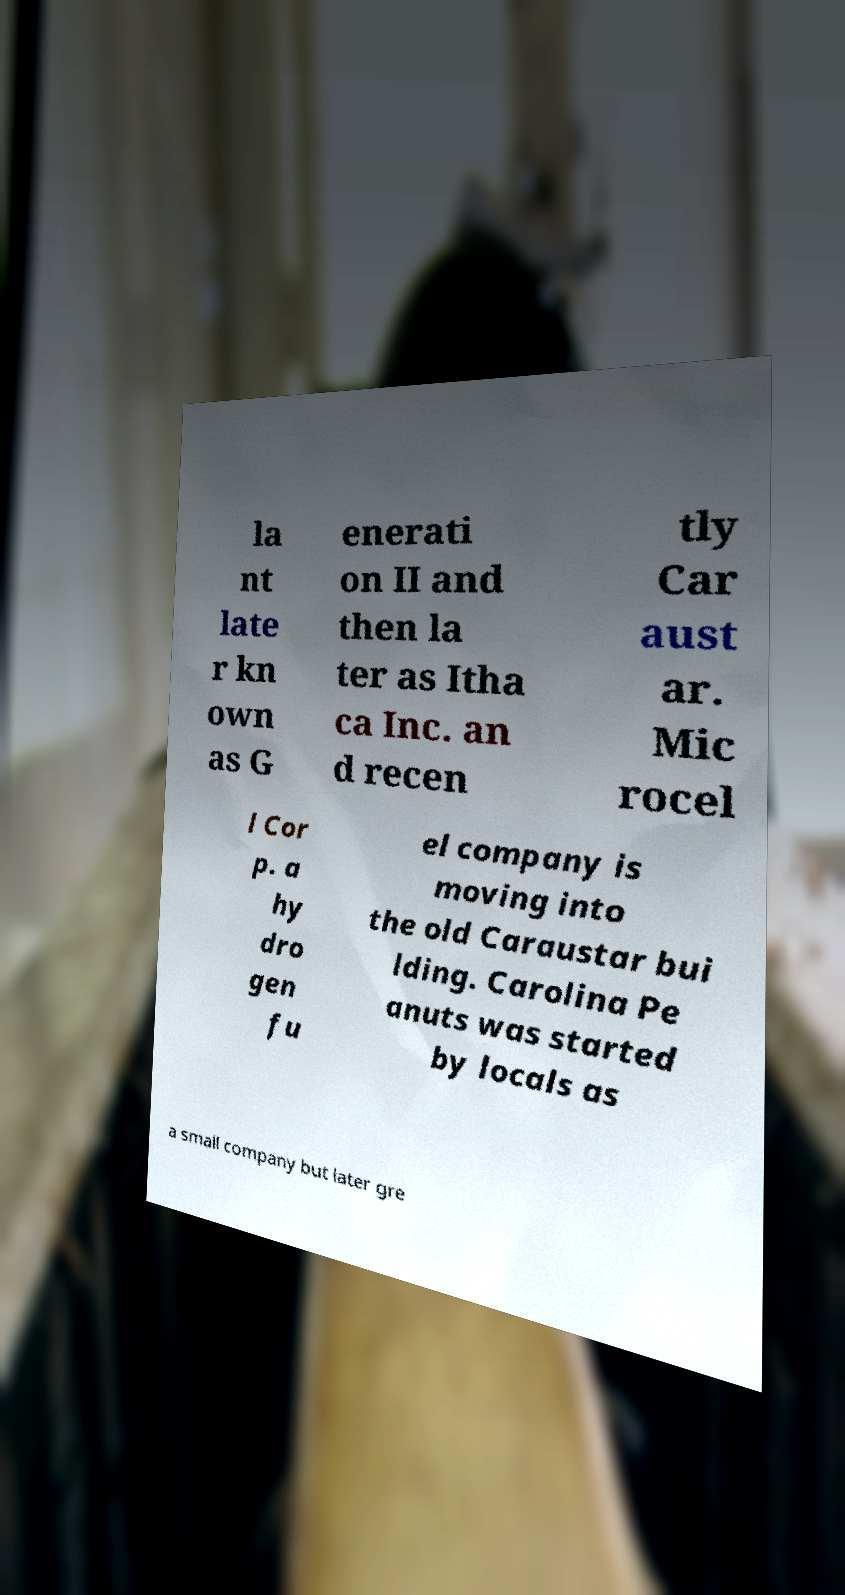What messages or text are displayed in this image? I need them in a readable, typed format. la nt late r kn own as G enerati on II and then la ter as Itha ca Inc. an d recen tly Car aust ar. Mic rocel l Cor p. a hy dro gen fu el company is moving into the old Caraustar bui lding. Carolina Pe anuts was started by locals as a small company but later gre 